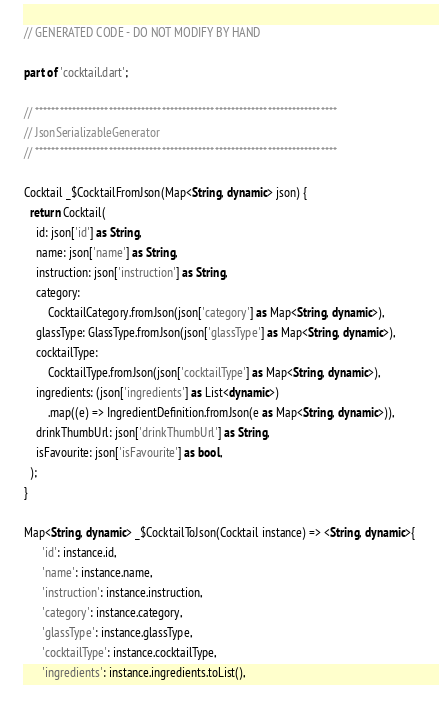<code> <loc_0><loc_0><loc_500><loc_500><_Dart_>// GENERATED CODE - DO NOT MODIFY BY HAND

part of 'cocktail.dart';

// **************************************************************************
// JsonSerializableGenerator
// **************************************************************************

Cocktail _$CocktailFromJson(Map<String, dynamic> json) {
  return Cocktail(
    id: json['id'] as String,
    name: json['name'] as String,
    instruction: json['instruction'] as String,
    category:
        CocktailCategory.fromJson(json['category'] as Map<String, dynamic>),
    glassType: GlassType.fromJson(json['glassType'] as Map<String, dynamic>),
    cocktailType:
        CocktailType.fromJson(json['cocktailType'] as Map<String, dynamic>),
    ingredients: (json['ingredients'] as List<dynamic>)
        .map((e) => IngredientDefinition.fromJson(e as Map<String, dynamic>)),
    drinkThumbUrl: json['drinkThumbUrl'] as String,
    isFavourite: json['isFavourite'] as bool,
  );
}

Map<String, dynamic> _$CocktailToJson(Cocktail instance) => <String, dynamic>{
      'id': instance.id,
      'name': instance.name,
      'instruction': instance.instruction,
      'category': instance.category,
      'glassType': instance.glassType,
      'cocktailType': instance.cocktailType,
      'ingredients': instance.ingredients.toList(),</code> 